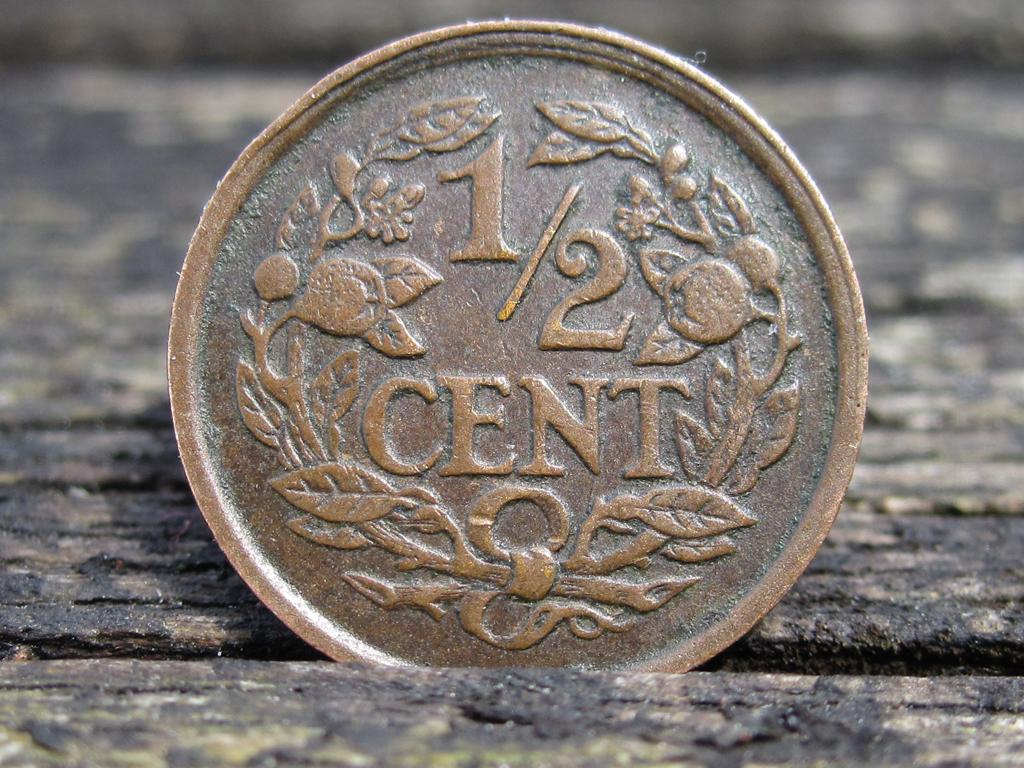<image>
Create a compact narrative representing the image presented. A metallic coin that says 1/2 cent on it is on a wooden surface. 